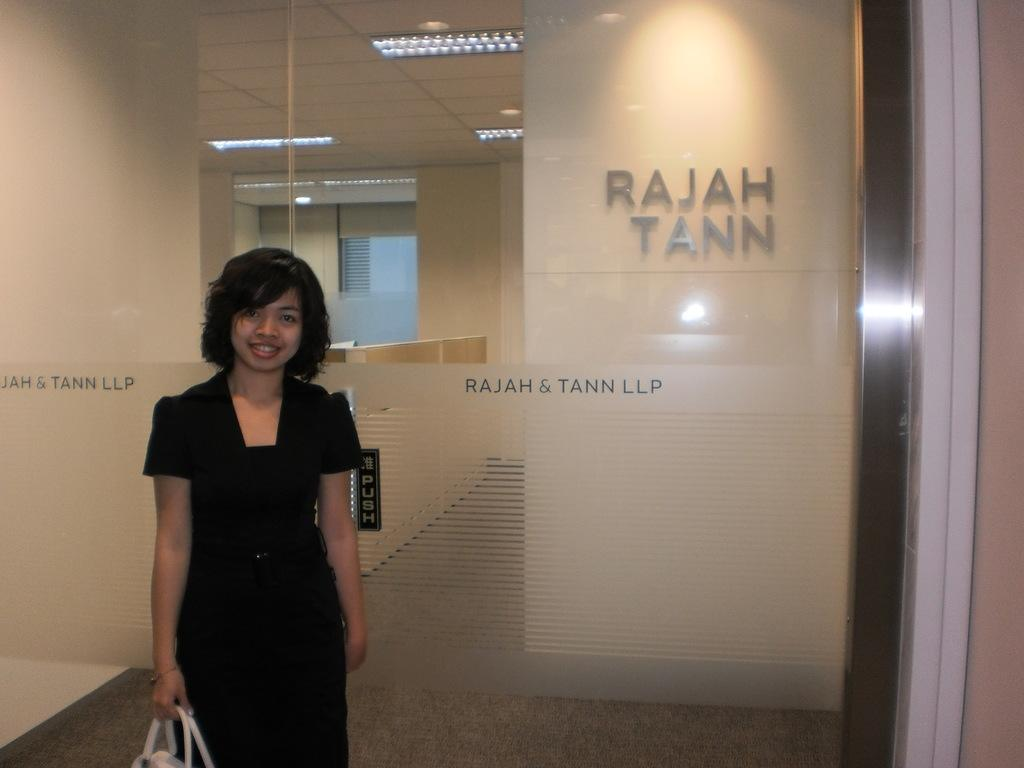What is the appearance of the person in the image? There is a beautiful girl in the image. What is the girl's expression in the image? The girl is smiling in the image. What is the girl wearing in the image? The girl is wearing a black dress in the image. What type of walls can be seen behind the girl? There are glass walls behind the girl in the image. What can be seen at the top of the image? There are ceiling lights visible at the top of the image. What type of authority does the girl have in the image? There is no indication of the girl having any authority in the image. Can you tell me how many chess pieces are on the table in the image? There is no table or chess pieces present in the image. 